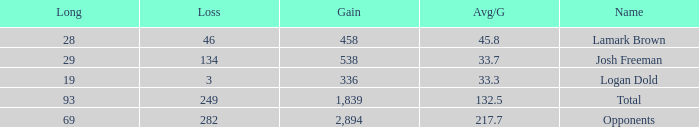How much Gain has a Long of 29, and an Avg/G smaller than 33.7? 0.0. 